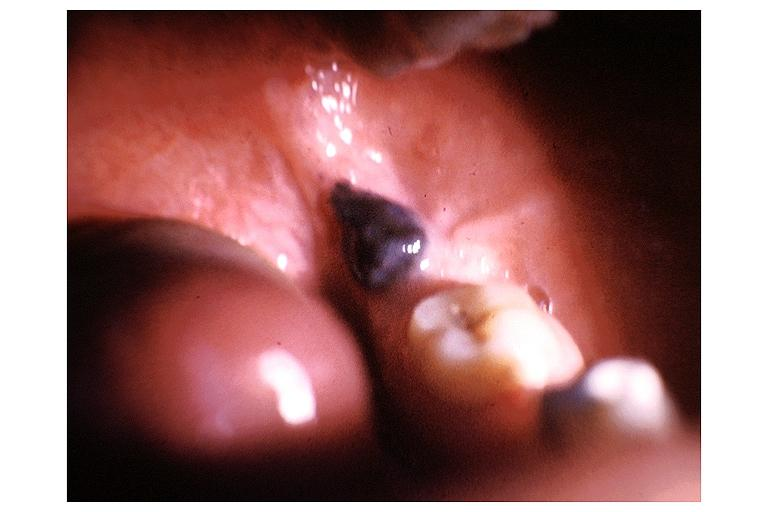what is present?
Answer the question using a single word or phrase. Oral 